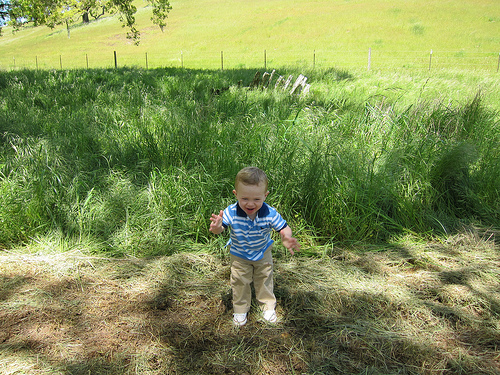<image>
Can you confirm if the child is under the grass? No. The child is not positioned under the grass. The vertical relationship between these objects is different. Where is the fence in relation to the field? Is it in front of the field? Yes. The fence is positioned in front of the field, appearing closer to the camera viewpoint. Where is the kid in relation to the dirt? Is it above the dirt? No. The kid is not positioned above the dirt. The vertical arrangement shows a different relationship. 